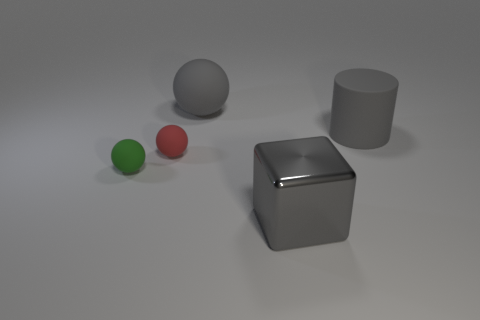Subtract all red balls. How many balls are left? 2 Add 1 big blue cubes. How many objects exist? 6 Subtract all spheres. How many objects are left? 2 Subtract 1 spheres. How many spheres are left? 2 Subtract 0 cyan cylinders. How many objects are left? 5 Subtract all blue balls. Subtract all cyan blocks. How many balls are left? 3 Subtract all gray cylinders. How many red blocks are left? 0 Subtract all large cylinders. Subtract all tiny matte objects. How many objects are left? 2 Add 3 big gray matte things. How many big gray matte things are left? 5 Add 5 large green shiny blocks. How many large green shiny blocks exist? 5 